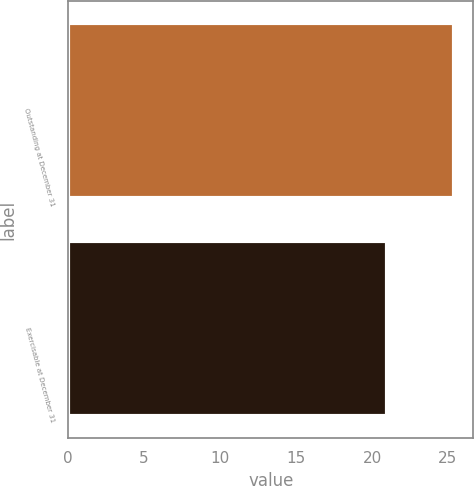<chart> <loc_0><loc_0><loc_500><loc_500><bar_chart><fcel>Outstanding at December 31<fcel>Exercisable at December 31<nl><fcel>25.4<fcel>21<nl></chart> 